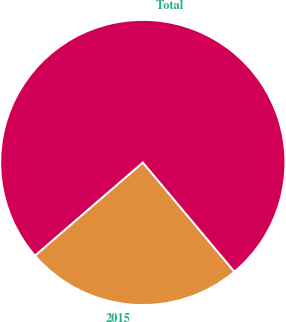Convert chart. <chart><loc_0><loc_0><loc_500><loc_500><pie_chart><fcel>2015<fcel>Total<nl><fcel>24.77%<fcel>75.23%<nl></chart> 